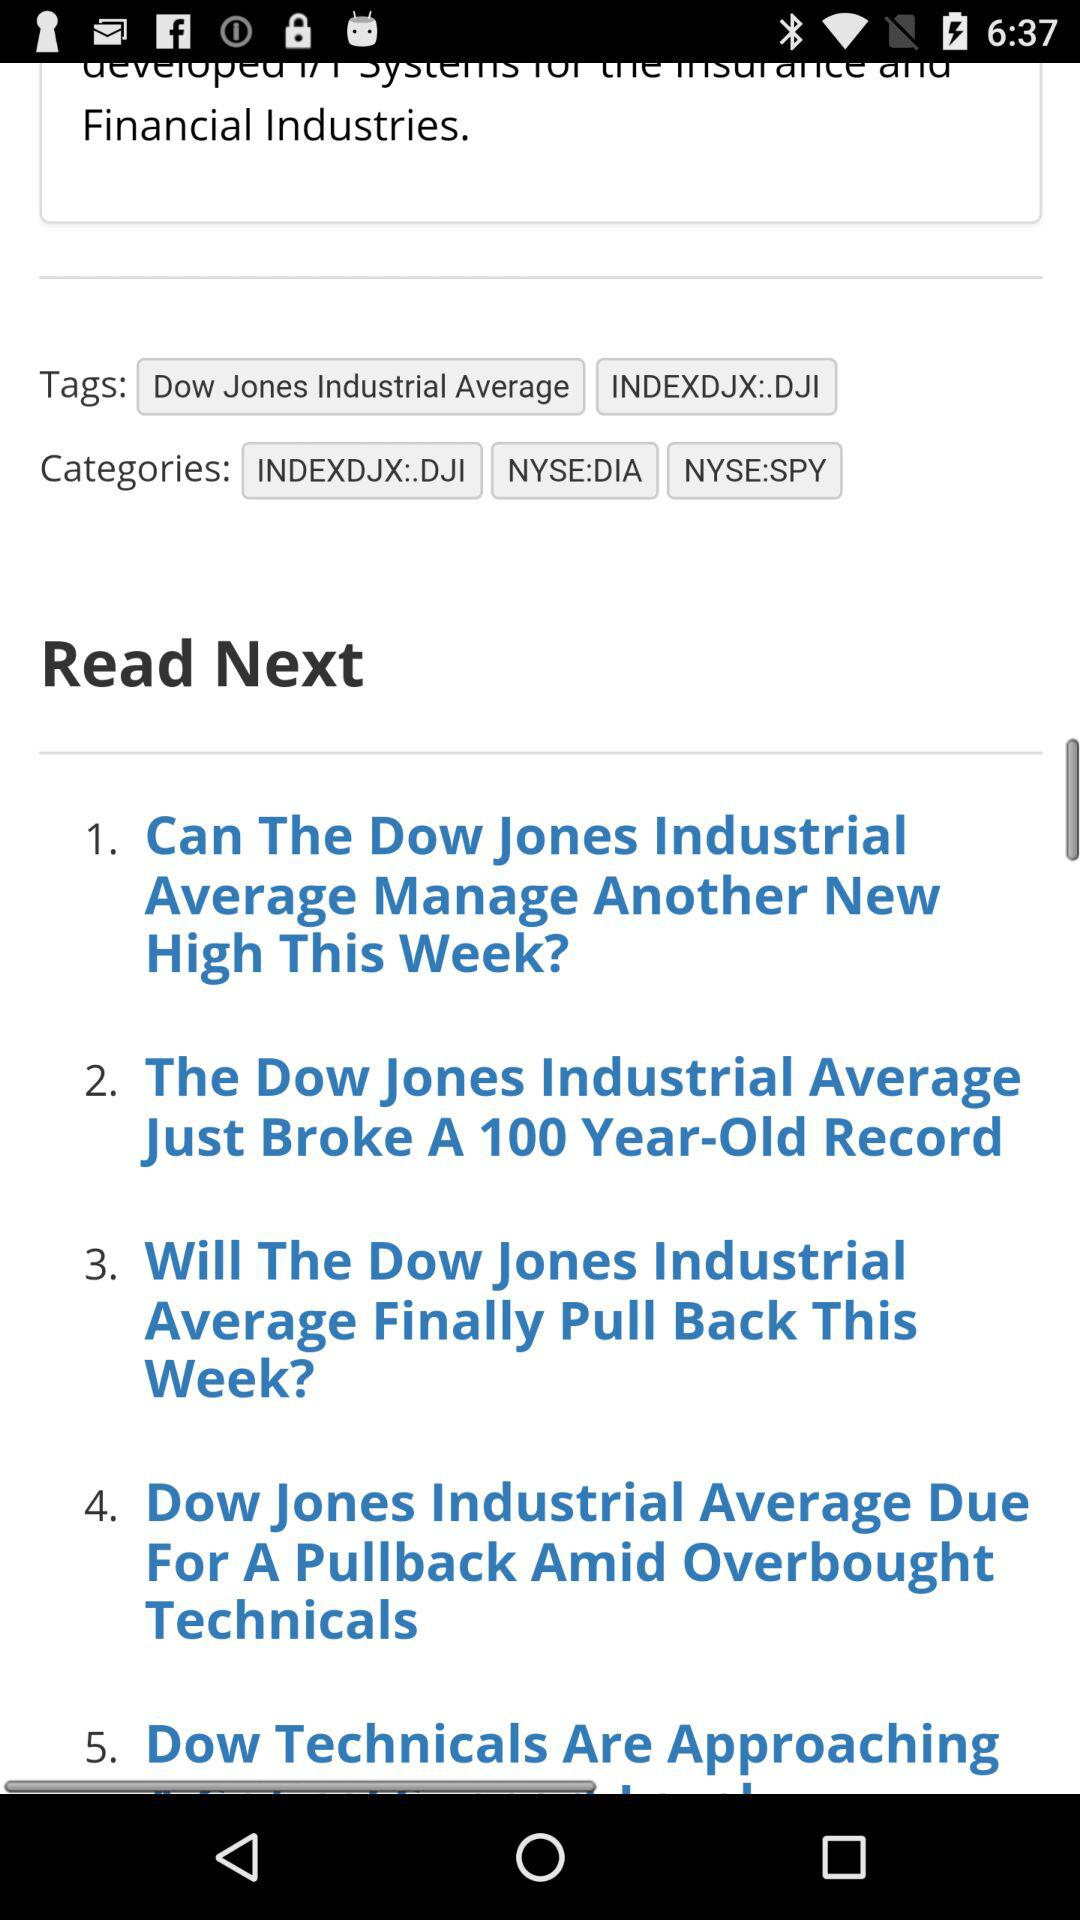How many articles are there about the Dow Jones Industrial Average?
Answer the question using a single word or phrase. 5 